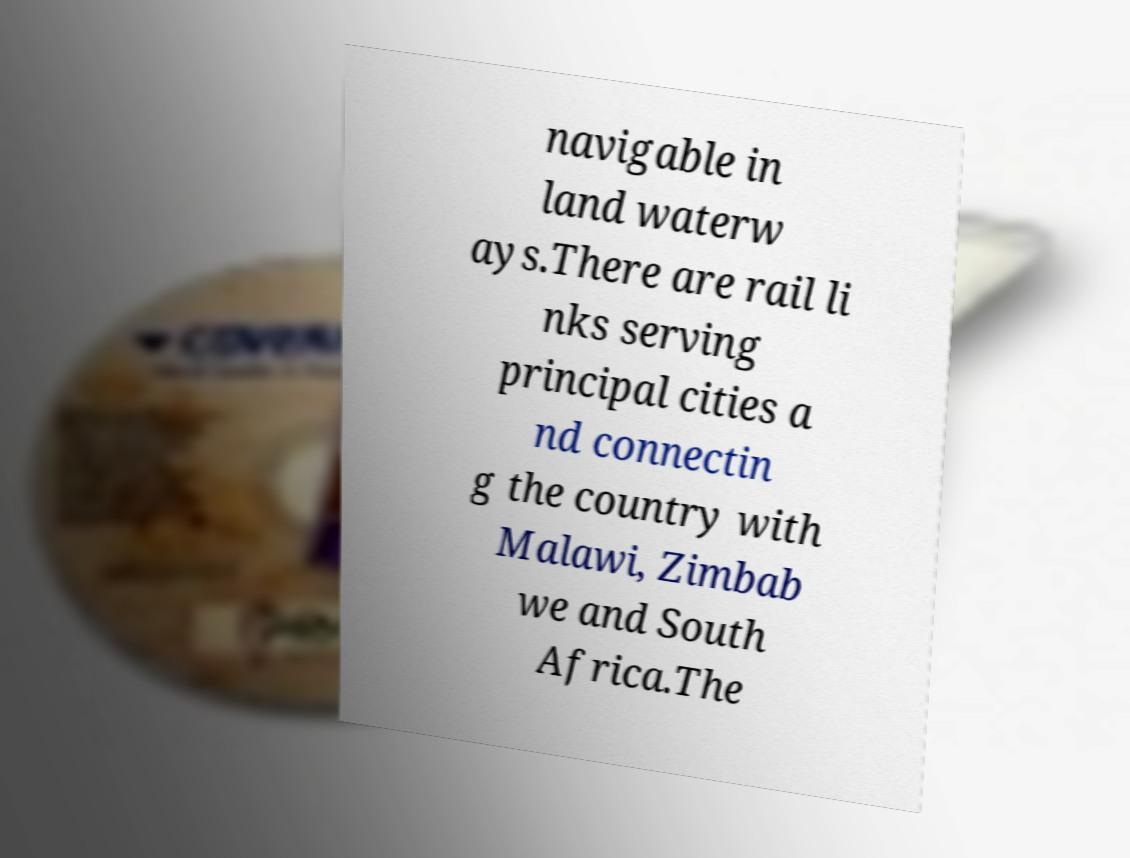There's text embedded in this image that I need extracted. Can you transcribe it verbatim? navigable in land waterw ays.There are rail li nks serving principal cities a nd connectin g the country with Malawi, Zimbab we and South Africa.The 